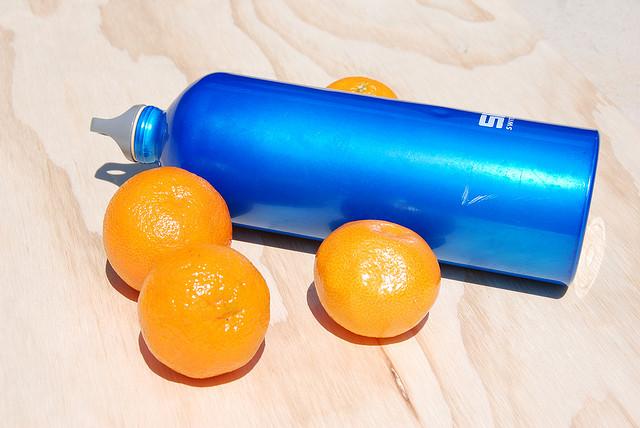What kind of juice can you make by squeezing the fruit in the photo?
Answer briefly. Orange juice. Are there apples in this picture?
Write a very short answer. No. How many pieces of fruit are visible?
Concise answer only. 4. 